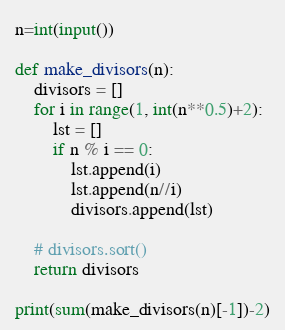<code> <loc_0><loc_0><loc_500><loc_500><_Python_>n=int(input())

def make_divisors(n):
	divisors = []
	for i in range(1, int(n**0.5)+2):
		lst = []
		if n % i == 0:
			lst.append(i)
			lst.append(n//i)
			divisors.append(lst)

	# divisors.sort()
	return divisors
	
print(sum(make_divisors(n)[-1])-2)</code> 